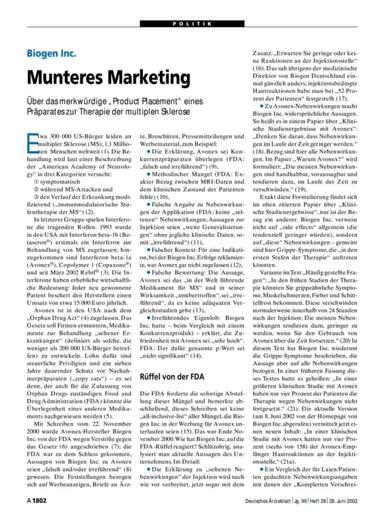What are the ethical implications discussed about Biogen Inc.'s marketing strategies? The text raises concerns regarding the ethical dimensions of Biogen Inc.'s marketing tactics, particularly questioning whether the strategies respect patient autonomy and the implications of aggressive marketing on treatment perception. 